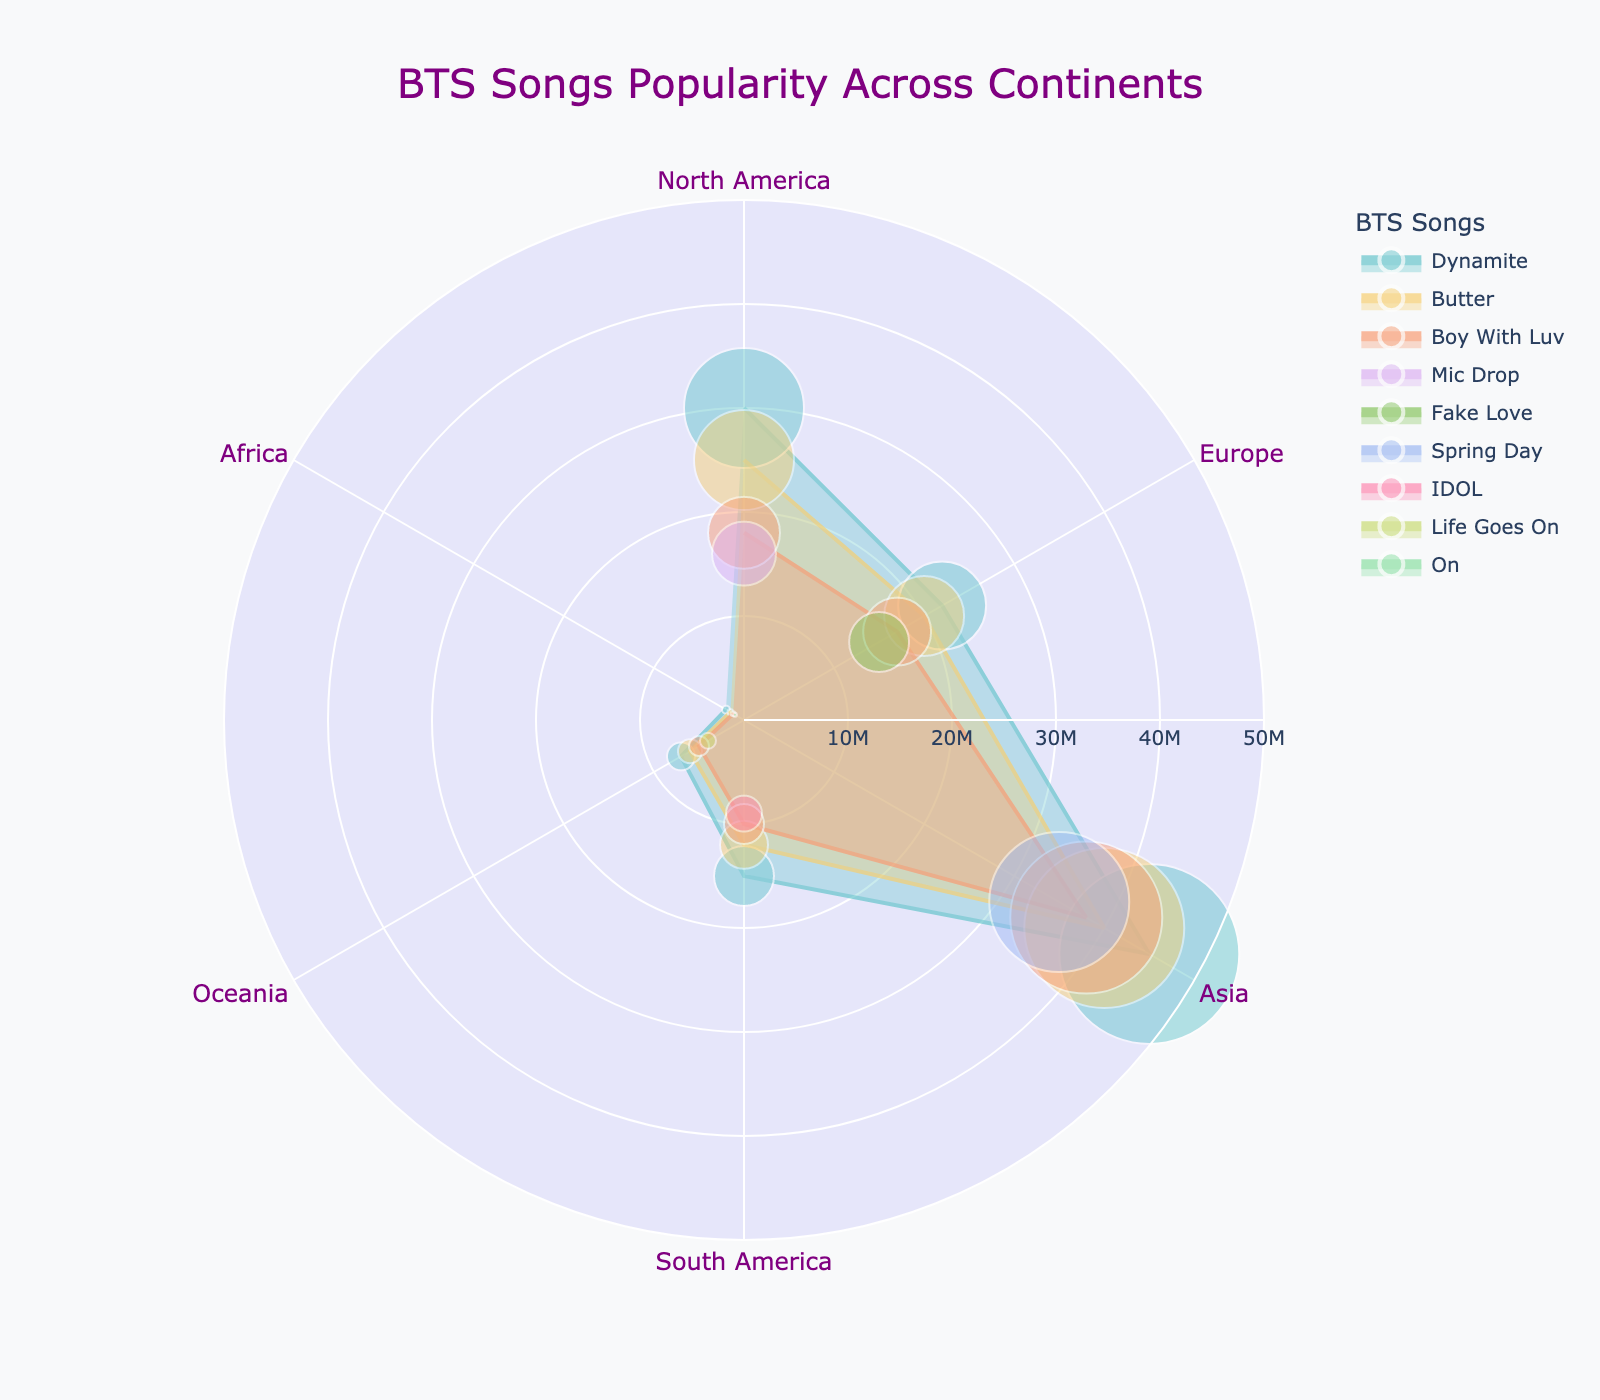What is the title of the figure? The title is usually displayed prominently at the top of the figure. In this case, it reads "BTS Songs Popularity Across Continents."
Answer: BTS Songs Popularity Across Continents Which BTS song has the highest number of streams in Asia? Look at the "Streams" values for each song within the "Asia" section. The highest value is for the song "Dynamite" with 45,000,000 streams.
Answer: Dynamite How many continents are represented in the figure? There are distinct labels on the angular axis representing continents. Counting them gives six continents: North America, Europe, Asia, South America, Oceania, and Africa.
Answer: Six What is the radial range used in the scatter plot? By reading the radial axis labels, we see it ranges from 0 to 50,000,000 streams.
Answer: 0 to 50,000,000 Which continent has the lowest number of streams for "Boy With Luv"? Look at the radial values for "Boy With Luv" in each continent. The lowest value is in Africa with 1,200,000 streams.
Answer: Africa What is the difference in streams for "Butter" between North America and South America? Streams for "Butter" in North America are 25,000,000, and in South America, they are 12,000,000. The difference is 25,000,000 - 12,000,000 = 13,000,000.
Answer: 13,000,000 Across all continents, which song has the most consistent streaming numbers? Consistency can be assessed by examining the deviation in radial values. "Boy With Luv" shows relatively similar values across continents: 18,000,000 (North America), 17,000,000 (Europe), 38,000,000 (Asia), 10,000,000 (South America), 5,000,000 (Oceania), 1,200,000 (Africa). This implies it is less consistent compared to "Butter" which shows closer values within a smaller range.
Answer: Butter Which song experiences the largest drop in streams from one continent to the next? Comparing drops between continents for each song, "Dynamite" experiences the largest drop, dropping from 45,000,000 in Asia to 22,000,000 in Europe—a drop of 23,000,000 streams.
Answer: Dynamite How does the popularity of "Dynamite" compare between Asia and Oceania? "Dynamite" has 45,000,000 streams in Asia and 7,000,000 streams in Oceania. These figures indicate significantly higher popularity in Asia.
Answer: Higher in Asia 